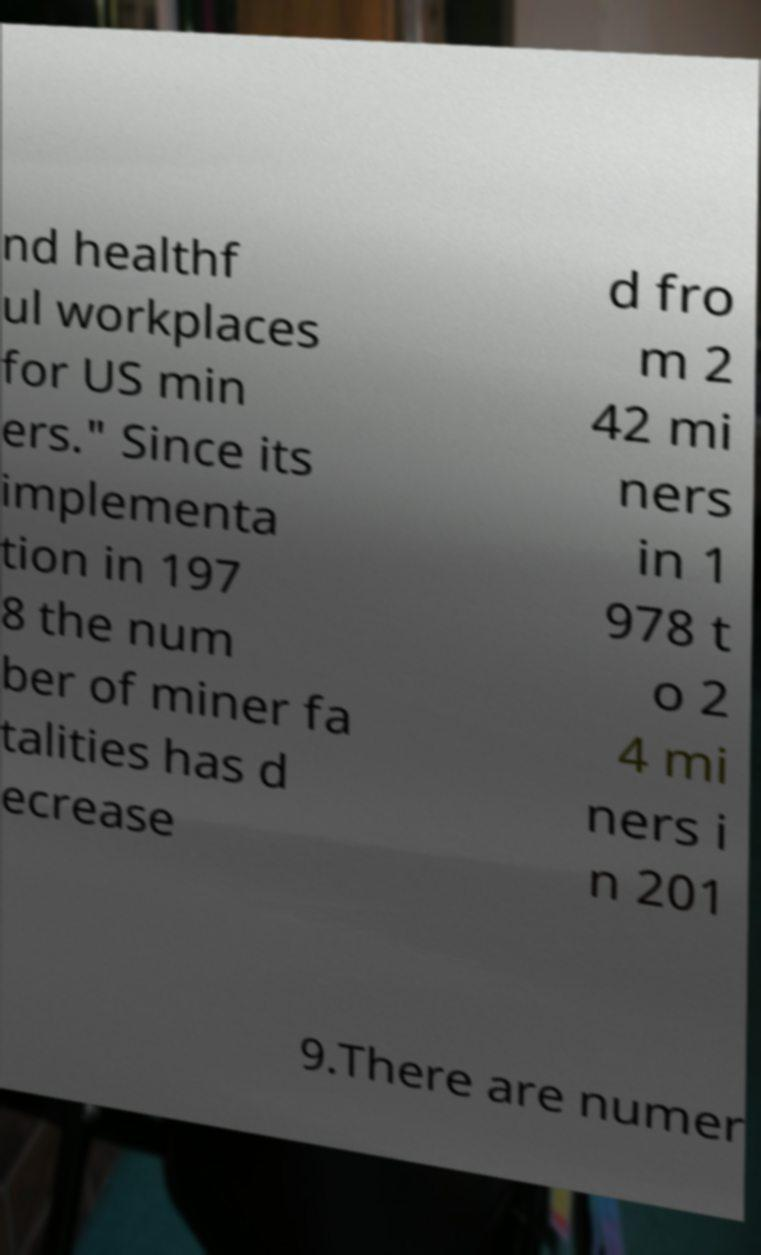There's text embedded in this image that I need extracted. Can you transcribe it verbatim? nd healthf ul workplaces for US min ers." Since its implementa tion in 197 8 the num ber of miner fa talities has d ecrease d fro m 2 42 mi ners in 1 978 t o 2 4 mi ners i n 201 9.There are numer 